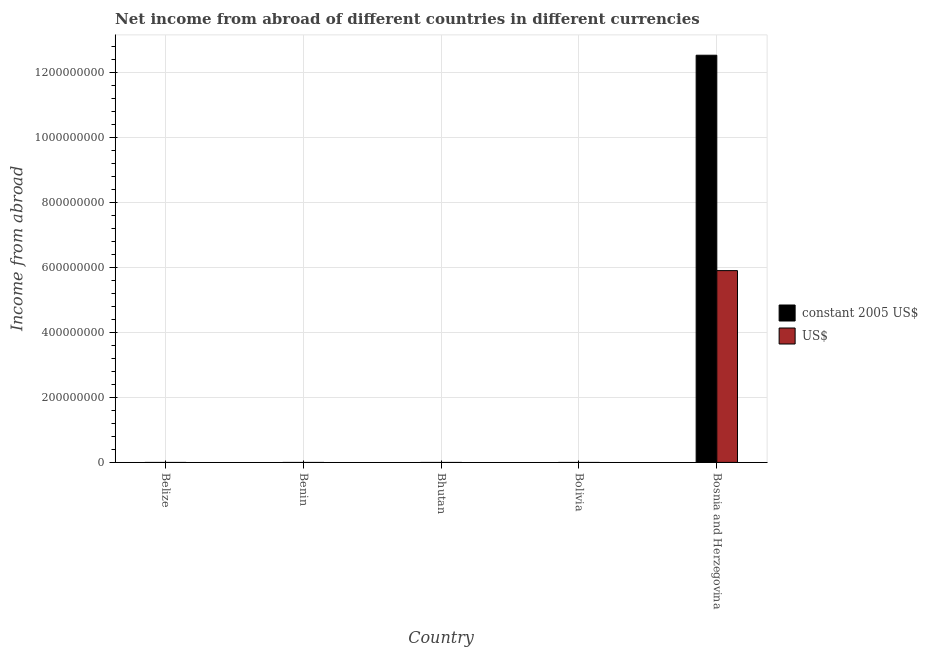Are the number of bars per tick equal to the number of legend labels?
Keep it short and to the point. No. Are the number of bars on each tick of the X-axis equal?
Give a very brief answer. No. How many bars are there on the 2nd tick from the left?
Provide a succinct answer. 0. How many bars are there on the 3rd tick from the right?
Make the answer very short. 0. What is the label of the 2nd group of bars from the left?
Provide a succinct answer. Benin. What is the income from abroad in constant 2005 us$ in Bolivia?
Provide a succinct answer. 0. Across all countries, what is the maximum income from abroad in constant 2005 us$?
Make the answer very short. 1.25e+09. Across all countries, what is the minimum income from abroad in us$?
Your answer should be compact. 0. In which country was the income from abroad in us$ maximum?
Your response must be concise. Bosnia and Herzegovina. What is the total income from abroad in us$ in the graph?
Your response must be concise. 5.90e+08. What is the average income from abroad in us$ per country?
Offer a terse response. 1.18e+08. What is the difference between the highest and the lowest income from abroad in constant 2005 us$?
Provide a succinct answer. 1.25e+09. How many legend labels are there?
Your answer should be very brief. 2. What is the title of the graph?
Offer a very short reply. Net income from abroad of different countries in different currencies. Does "Non-resident workers" appear as one of the legend labels in the graph?
Ensure brevity in your answer.  No. What is the label or title of the Y-axis?
Ensure brevity in your answer.  Income from abroad. What is the Income from abroad of constant 2005 US$ in Belize?
Your answer should be compact. 0. What is the Income from abroad of constant 2005 US$ in Benin?
Make the answer very short. 0. What is the Income from abroad in US$ in Bhutan?
Make the answer very short. 0. What is the Income from abroad in constant 2005 US$ in Bolivia?
Give a very brief answer. 0. What is the Income from abroad of constant 2005 US$ in Bosnia and Herzegovina?
Provide a short and direct response. 1.25e+09. What is the Income from abroad of US$ in Bosnia and Herzegovina?
Make the answer very short. 5.90e+08. Across all countries, what is the maximum Income from abroad in constant 2005 US$?
Your answer should be very brief. 1.25e+09. Across all countries, what is the maximum Income from abroad of US$?
Keep it short and to the point. 5.90e+08. What is the total Income from abroad in constant 2005 US$ in the graph?
Your answer should be compact. 1.25e+09. What is the total Income from abroad in US$ in the graph?
Your answer should be very brief. 5.90e+08. What is the average Income from abroad in constant 2005 US$ per country?
Keep it short and to the point. 2.50e+08. What is the average Income from abroad in US$ per country?
Provide a succinct answer. 1.18e+08. What is the difference between the Income from abroad of constant 2005 US$ and Income from abroad of US$ in Bosnia and Herzegovina?
Ensure brevity in your answer.  6.62e+08. What is the difference between the highest and the lowest Income from abroad of constant 2005 US$?
Ensure brevity in your answer.  1.25e+09. What is the difference between the highest and the lowest Income from abroad in US$?
Ensure brevity in your answer.  5.90e+08. 